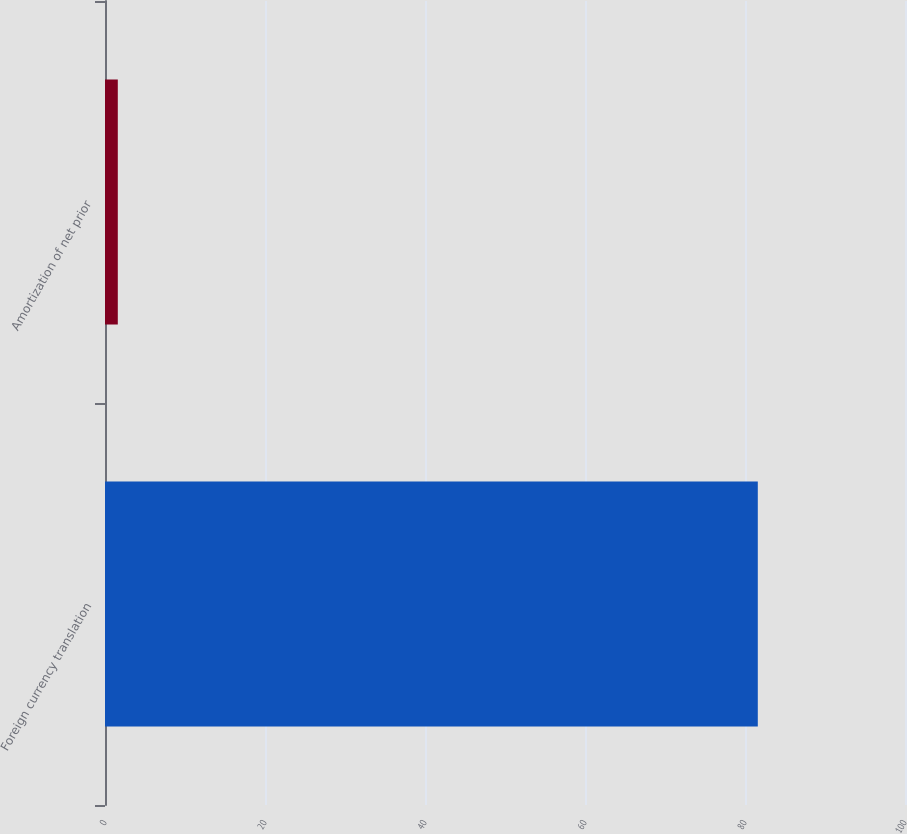Convert chart to OTSL. <chart><loc_0><loc_0><loc_500><loc_500><bar_chart><fcel>Foreign currency translation<fcel>Amortization of net prior<nl><fcel>81.6<fcel>1.6<nl></chart> 